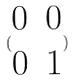Convert formula to latex. <formula><loc_0><loc_0><loc_500><loc_500>( \begin{matrix} 0 & 0 \\ 0 & 1 \end{matrix} )</formula> 